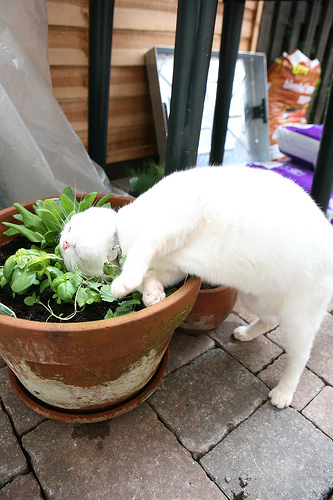What animal is white? The animal that is white is a cat. 